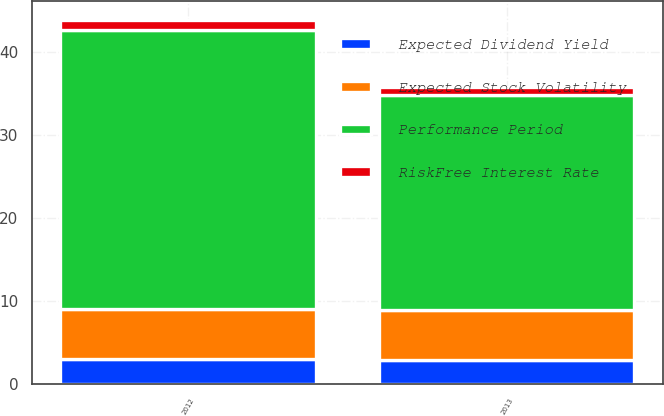Convert chart. <chart><loc_0><loc_0><loc_500><loc_500><stacked_bar_chart><ecel><fcel>2012<fcel>2013<nl><fcel>RiskFree Interest Rate<fcel>1.21<fcel>1.05<nl><fcel>Expected Stock Volatility<fcel>6<fcel>6<nl><fcel>Performance Period<fcel>33.63<fcel>25.85<nl><fcel>Expected Dividend Yield<fcel>2.99<fcel>2.89<nl></chart> 